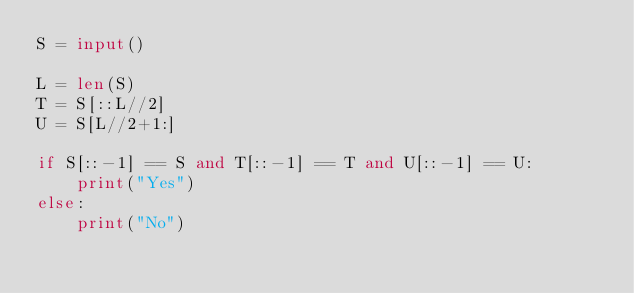<code> <loc_0><loc_0><loc_500><loc_500><_Python_>S = input()

L = len(S)
T = S[::L//2]
U = S[L//2+1:]

if S[::-1] == S and T[::-1] == T and U[::-1] == U:
    print("Yes")
else:
    print("No")</code> 